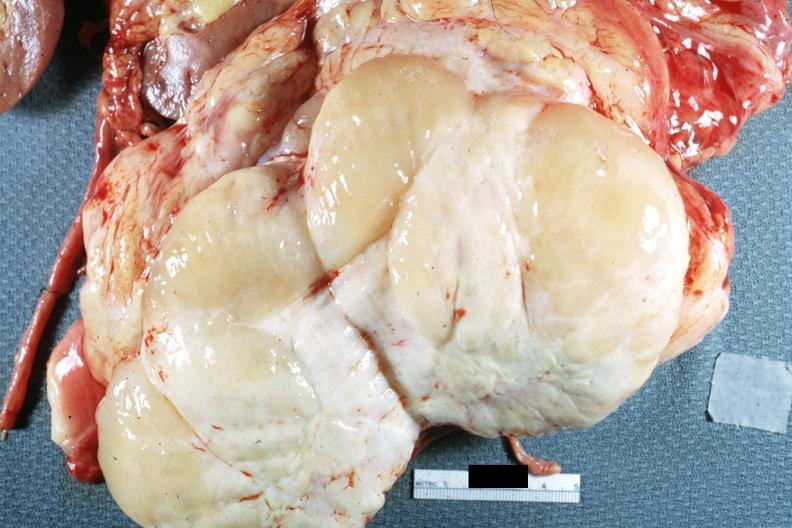s retroperitoneal liposarcoma present?
Answer the question using a single word or phrase. Yes 